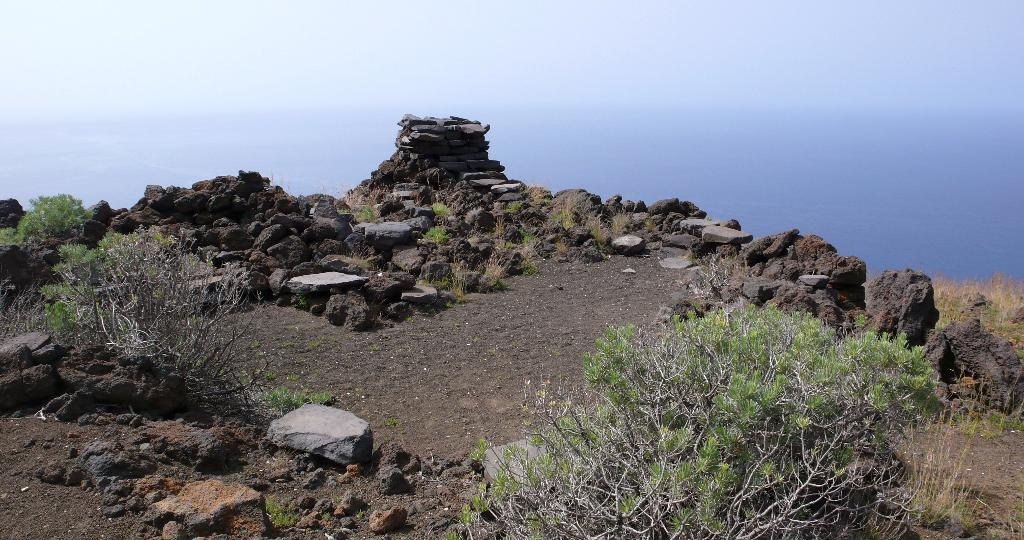What type of vegetation can be seen in the image? There are plants and grass in the image. What other elements can be found in the image? There are stones in the image. What can be seen in the background of the image? The sky is visible in the background of the image. What is the average income of the plantation workers in the image? There is no plantation or workers present in the image, so it is not possible to determine their income. 